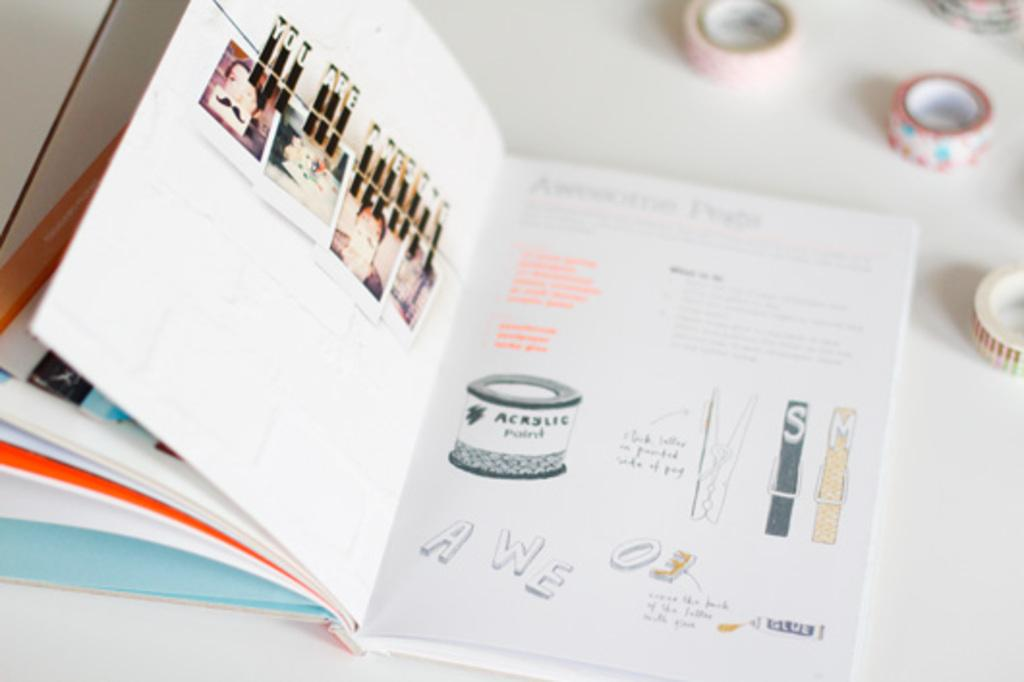<image>
Describe the image concisely. A book with an illustration of a jar of acrylic paint. 